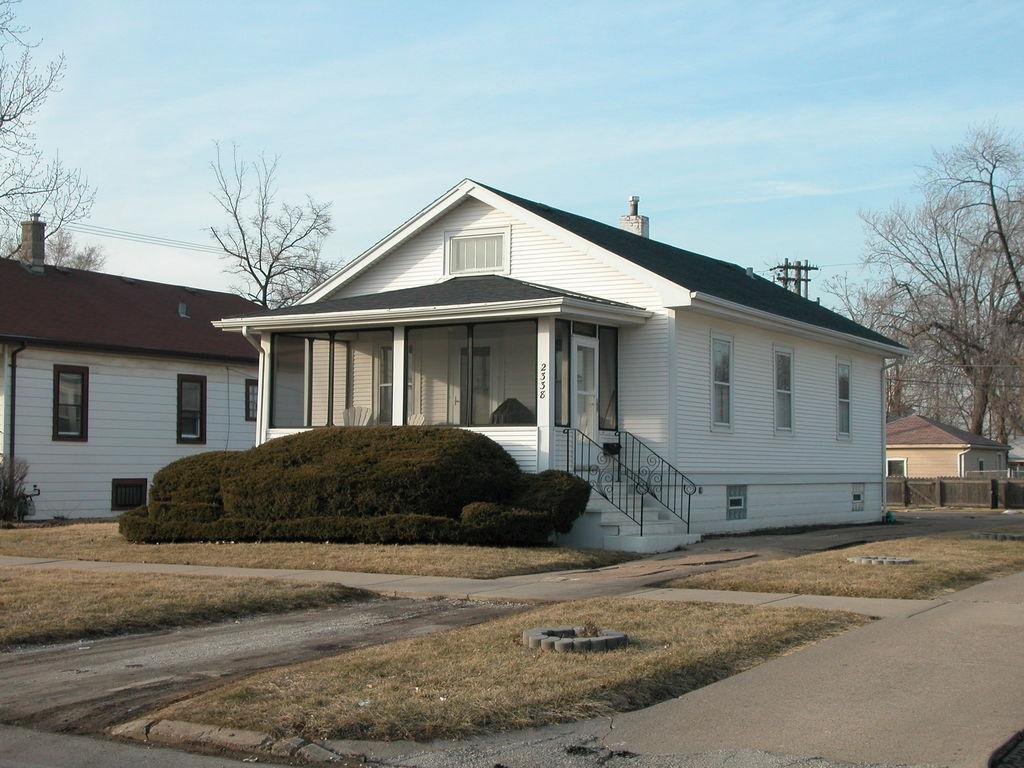What type of vegetation can be seen on the land in the image? There is dry grass on the land in the image. What other types of vegetation are present in the image? There are plants and dry trees in the image. What structure can be seen in the image? There is a fence in the image. What other structures are present in the image? There are poles and houses in the image. What is visible at the top of the image? The sky is visible at the top of the image. What type of coal can be seen in the image? There is no coal present in the image. Can you see a kitten playing with the rhythm in the image? There is no kitten or rhythm present in the image. 